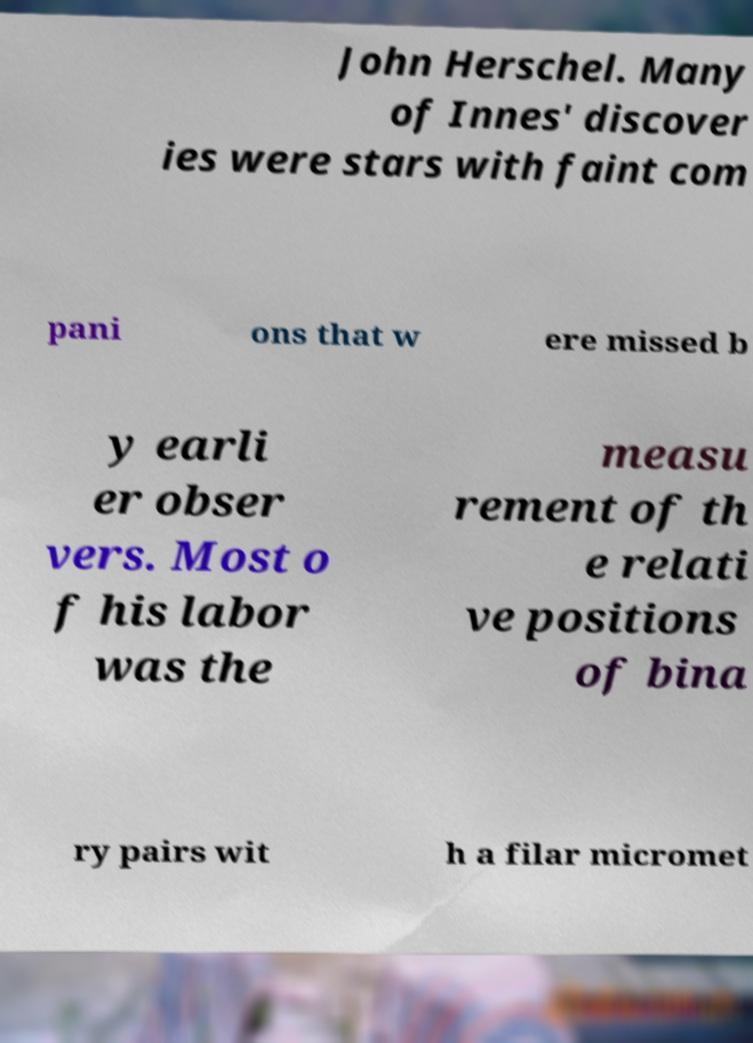There's text embedded in this image that I need extracted. Can you transcribe it verbatim? John Herschel. Many of Innes' discover ies were stars with faint com pani ons that w ere missed b y earli er obser vers. Most o f his labor was the measu rement of th e relati ve positions of bina ry pairs wit h a filar micromet 